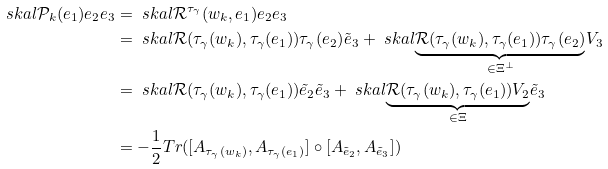Convert formula to latex. <formula><loc_0><loc_0><loc_500><loc_500>\ s k a l { \mathcal { P } _ { k } ( e _ { 1 } ) e _ { 2 } } { e _ { 3 } } & = \ s k a l { \mathcal { R } ^ { \tau _ { \gamma } } ( w _ { k } , e _ { 1 } ) e _ { 2 } } { e _ { 3 } } \\ & = \ s k a l { \mathcal { R } ( \tau _ { \gamma } ( w _ { k } ) , \tau _ { \gamma } ( e _ { 1 } ) ) \tau _ { \gamma } ( e _ { 2 } ) } { \tilde { e } _ { 3 } } + \ s k a l { \underbrace { \mathcal { R } ( \tau _ { \gamma } ( w _ { k } ) , \tau _ { \gamma } ( e _ { 1 } ) ) \tau _ { \gamma } ( e _ { 2 } ) } _ { \in \Xi ^ { \perp } } } { V _ { 3 } } \\ & = \ s k a l { \mathcal { R } ( \tau _ { \gamma } ( w _ { k } ) , \tau _ { \gamma } ( e _ { 1 } ) ) \tilde { e } _ { 2 } } { \tilde { e } _ { 3 } } + \ s k a l { \underbrace { \mathcal { R } ( \tau _ { \gamma } ( w _ { k } ) , \tau _ { \gamma } ( e _ { 1 } ) ) V _ { 2 } } _ { \in \Xi } } { \tilde { e } _ { 3 } } \\ & = - \frac { 1 } { 2 } T r ( [ A _ { \tau _ { \gamma } ( w _ { k } ) } , A _ { \tau _ { \gamma } ( e _ { 1 } ) } ] \circ [ A _ { \tilde { e } _ { 2 } } , A _ { \tilde { e } _ { 3 } } ] )</formula> 